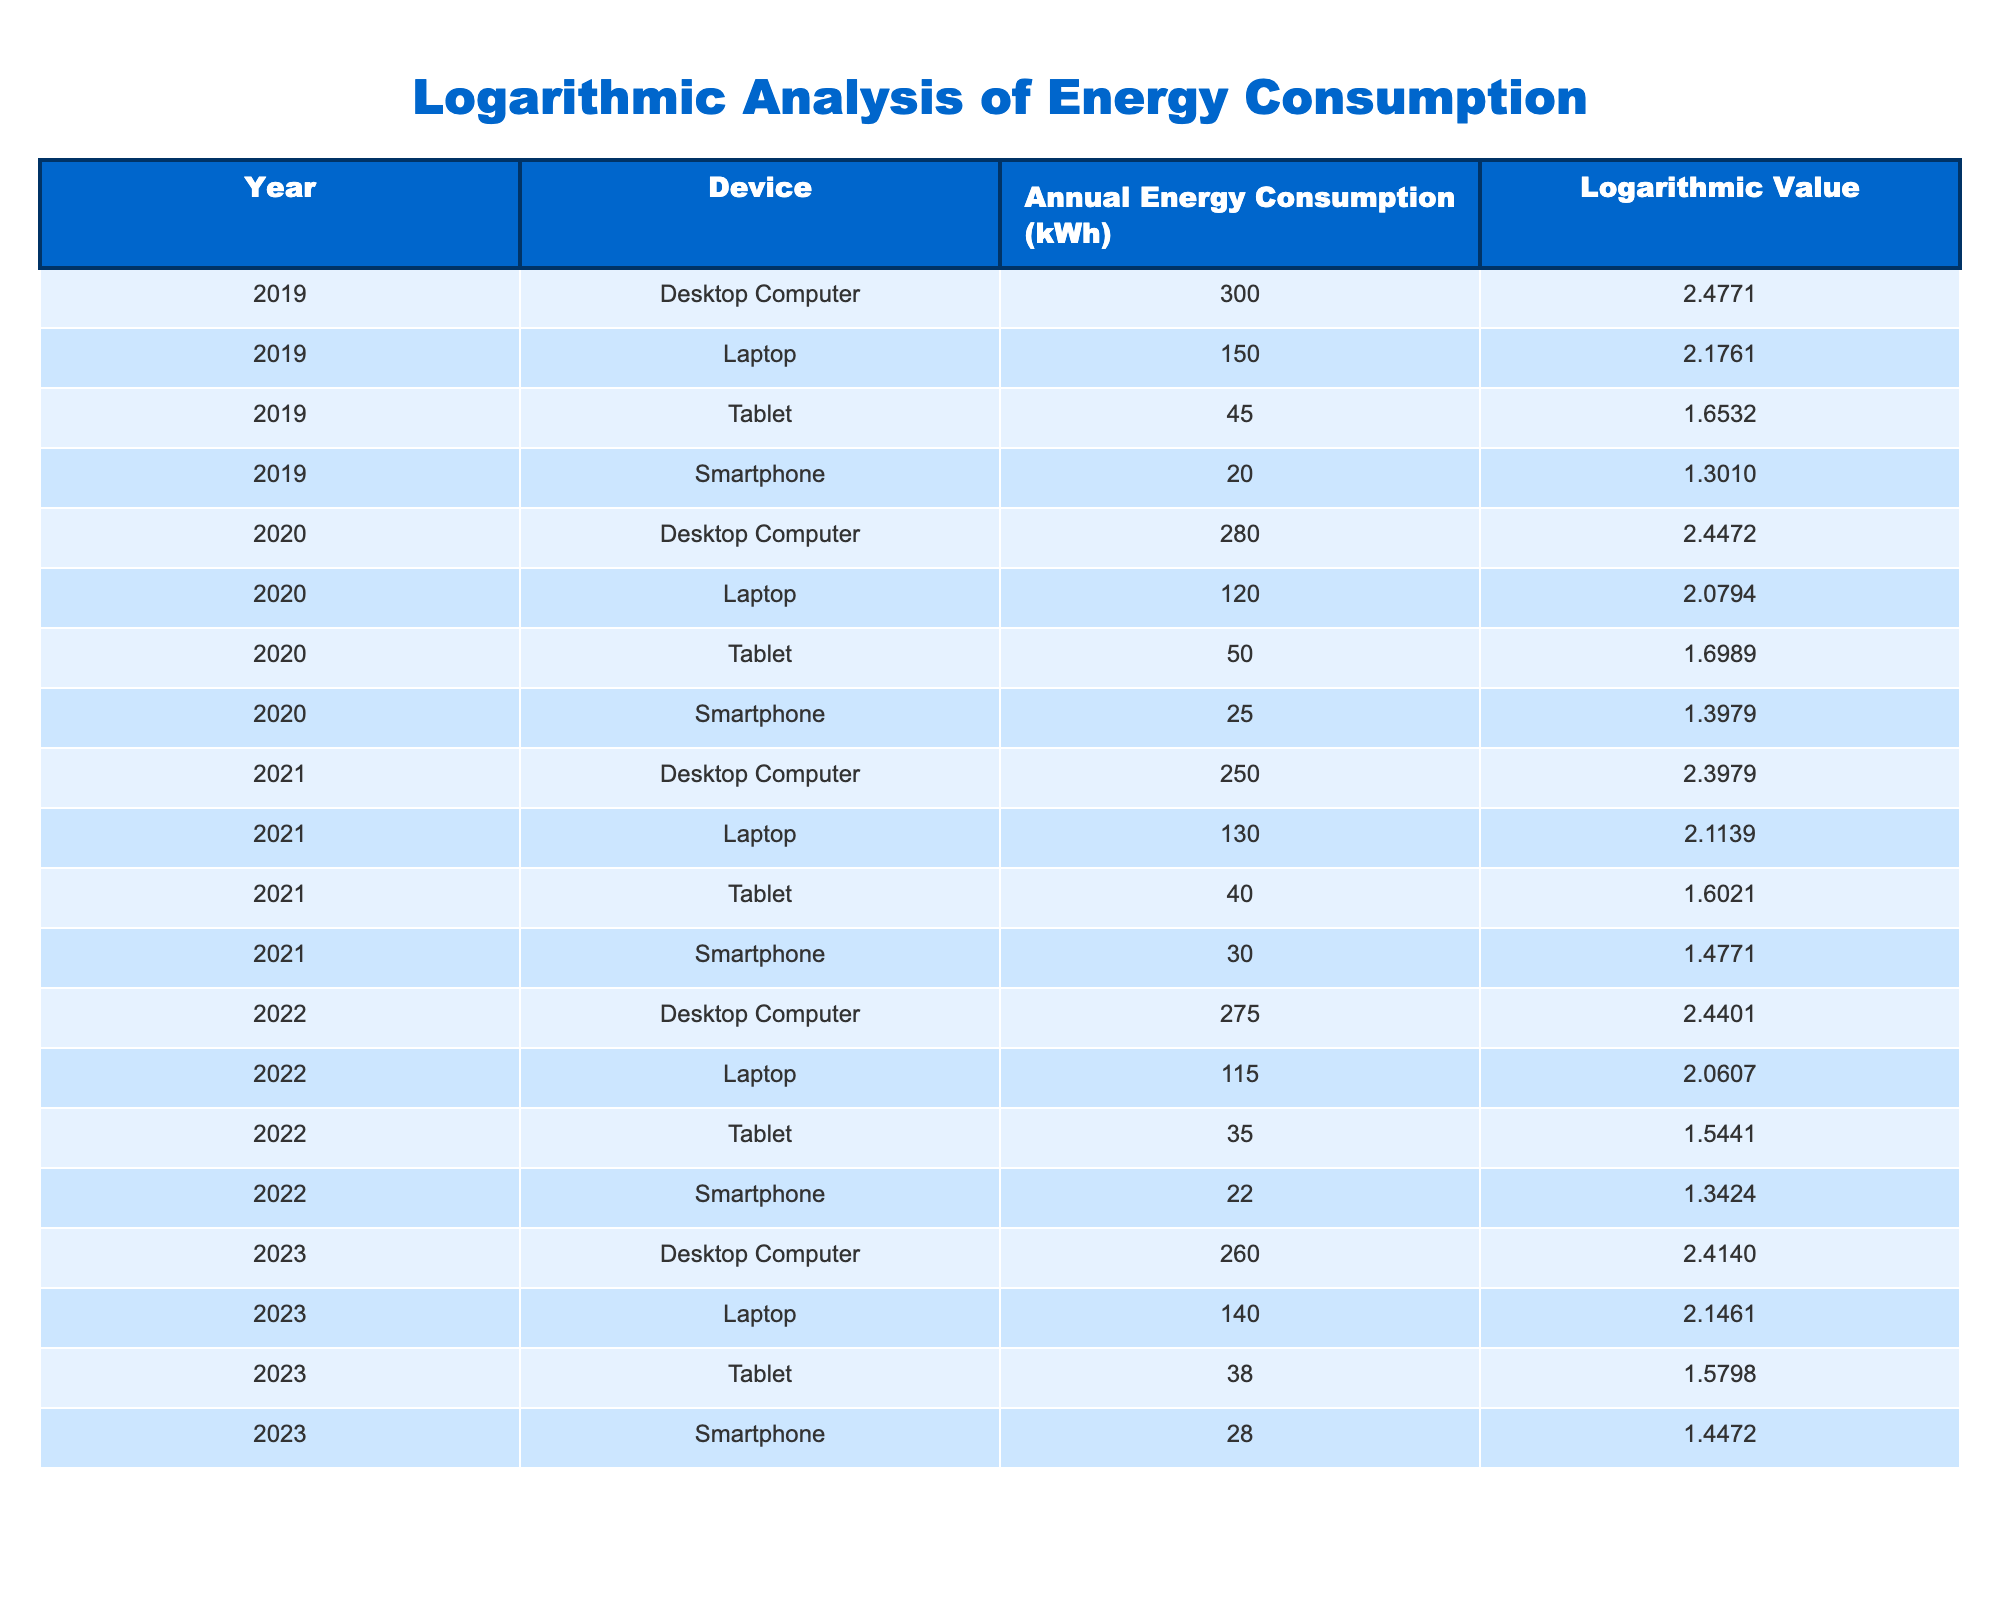What was the annual energy consumption of laptops in 2021? The table shows that the annual energy consumption of laptops in 2021 is listed as 130 kWh.
Answer: 130 kWh Which device had the highest annual energy consumption in 2019? From the table, the desktop computer has the highest annual energy consumption in 2019 at 300 kWh, compared to other devices listed for that year.
Answer: Desktop Computer What is the logarithmic value of the energy consumption of a smartphone in 2022? The table indicates that the logarithmic value for smartphone energy consumption in 2022 is 1.3424, which is directly listed.
Answer: 1.3424 What is the total annual energy consumption of tablets from 2019 to 2023? To calculate, we sum the annual energy consumption of tablets: 45 + 50 + 40 + 35 + 38 = 208 kWh. The total across these years is therefore 208 kWh.
Answer: 208 kWh Did the annual energy consumption of desktop computers increase or decrease from 2020 to 2021? The table shows that desktop computers consumed 280 kWh in 2020 and 250 kWh in 2021, indicating a decrease in energy consumption.
Answer: Decrease How does the logarithmic value of laptop energy consumption in 2023 compare to 2019? In 2023, the logarithmic value for laptops is 2.1461, and in 2019, it was 2.1761. Comparing these two values shows that 2.1461 is less than 2.1761, indicating a decrease in the logarithmic value over this period.
Answer: Decrease What was the average annual energy consumption of smartphones from 2019 to 2023? First, we sum the consumption: 20 + 25 + 30 + 22 + 28 = 125 kWh. Then, we divide by the number of years, which is 5: 125 kWh / 5 = 25 kWh. Thus, the average annual energy consumption of smartphones is 25 kWh.
Answer: 25 kWh Which device had the lowest logarithmic value in 2020? From the table, the smartphone in 2020 has the lowest logarithmic value of 1.3979 when compared to the other devices listed for that year.
Answer: Smartphone Was the annual energy consumption of laptops higher in 2022 than in 2021? The table shows that laptops consumed 115 kWh in 2022 and 130 kWh in 2021. Hence, the consumption in 2022 is lower than that in 2021.
Answer: No 